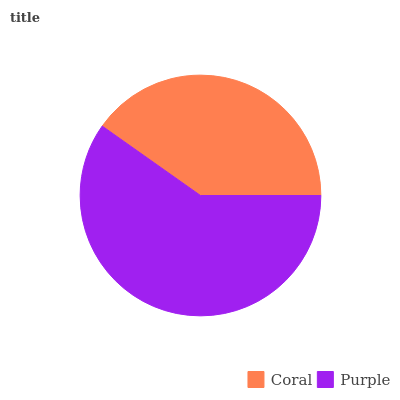Is Coral the minimum?
Answer yes or no. Yes. Is Purple the maximum?
Answer yes or no. Yes. Is Purple the minimum?
Answer yes or no. No. Is Purple greater than Coral?
Answer yes or no. Yes. Is Coral less than Purple?
Answer yes or no. Yes. Is Coral greater than Purple?
Answer yes or no. No. Is Purple less than Coral?
Answer yes or no. No. Is Purple the high median?
Answer yes or no. Yes. Is Coral the low median?
Answer yes or no. Yes. Is Coral the high median?
Answer yes or no. No. Is Purple the low median?
Answer yes or no. No. 